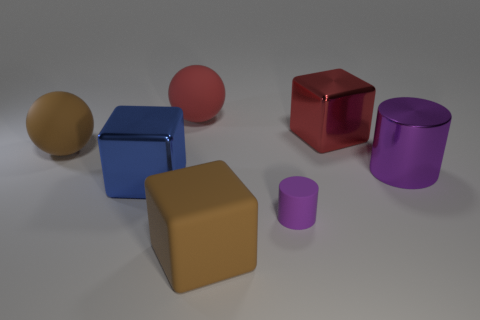Subtract all yellow cylinders. Subtract all brown balls. How many cylinders are left? 2 Add 1 big blue metal objects. How many objects exist? 8 Subtract all spheres. How many objects are left? 5 Add 1 tiny matte things. How many tiny matte things exist? 2 Subtract 2 purple cylinders. How many objects are left? 5 Subtract all tiny green rubber objects. Subtract all cylinders. How many objects are left? 5 Add 3 red spheres. How many red spheres are left? 4 